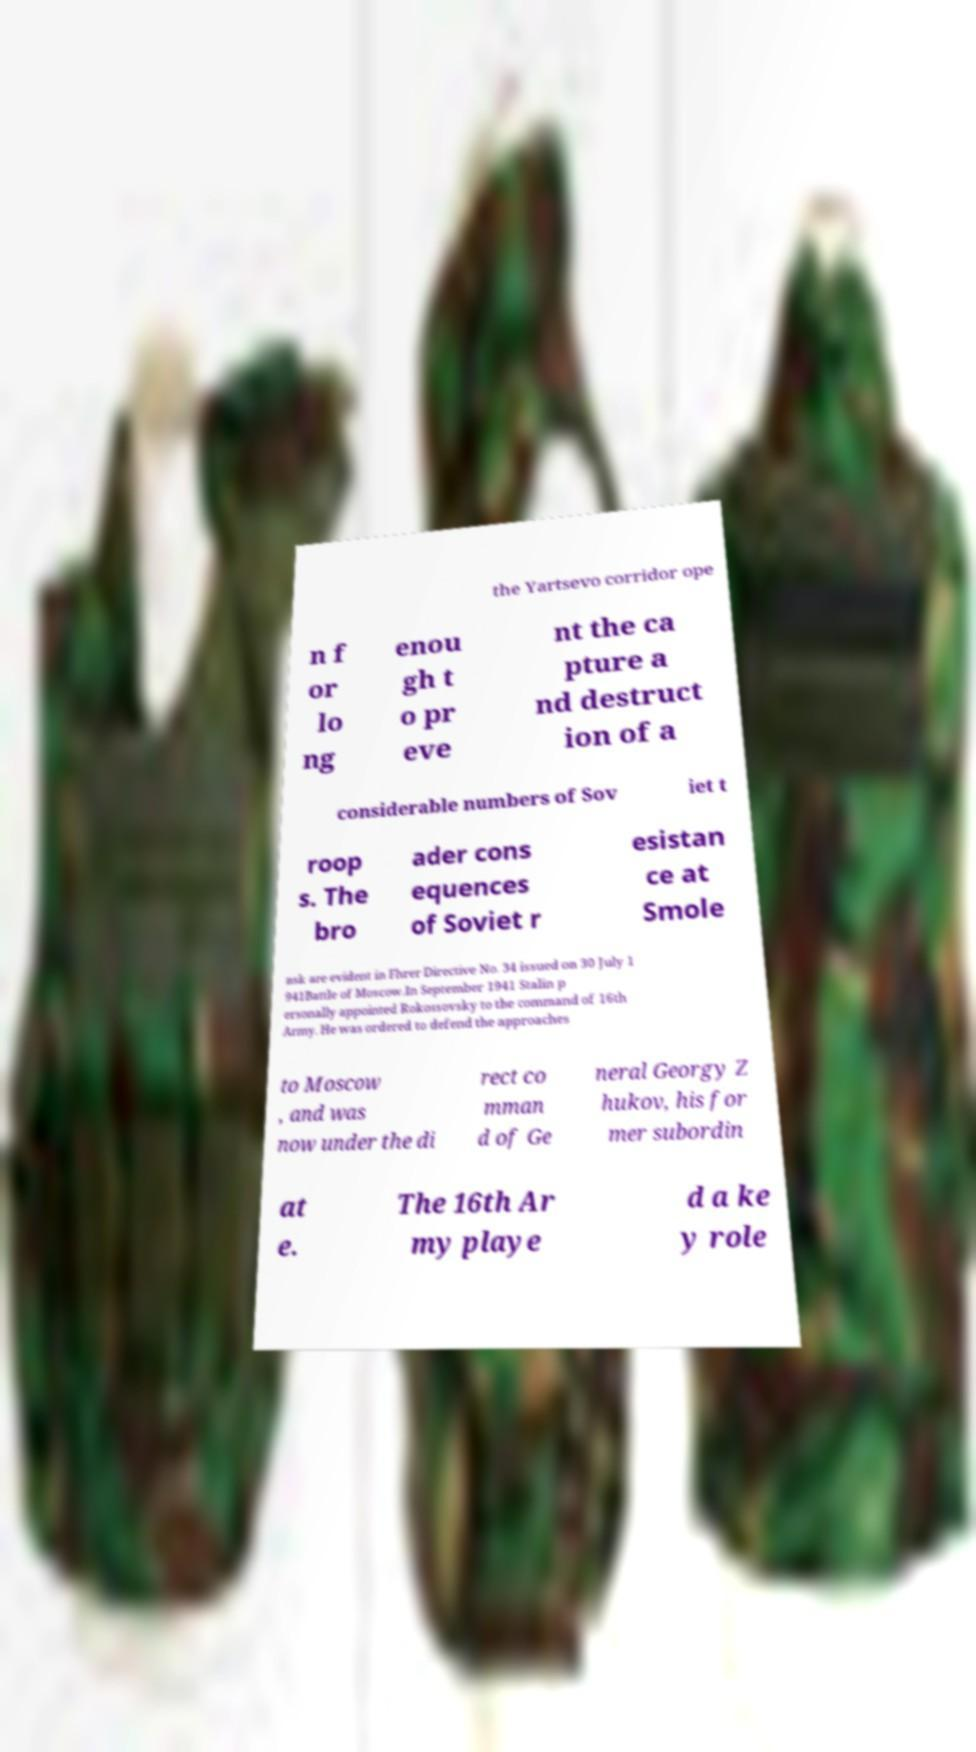Could you assist in decoding the text presented in this image and type it out clearly? the Yartsevo corridor ope n f or lo ng enou gh t o pr eve nt the ca pture a nd destruct ion of a considerable numbers of Sov iet t roop s. The bro ader cons equences of Soviet r esistan ce at Smole nsk are evident in Fhrer Directive No. 34 issued on 30 July 1 941Battle of Moscow.In September 1941 Stalin p ersonally appointed Rokossovsky to the command of 16th Army. He was ordered to defend the approaches to Moscow , and was now under the di rect co mman d of Ge neral Georgy Z hukov, his for mer subordin at e. The 16th Ar my playe d a ke y role 